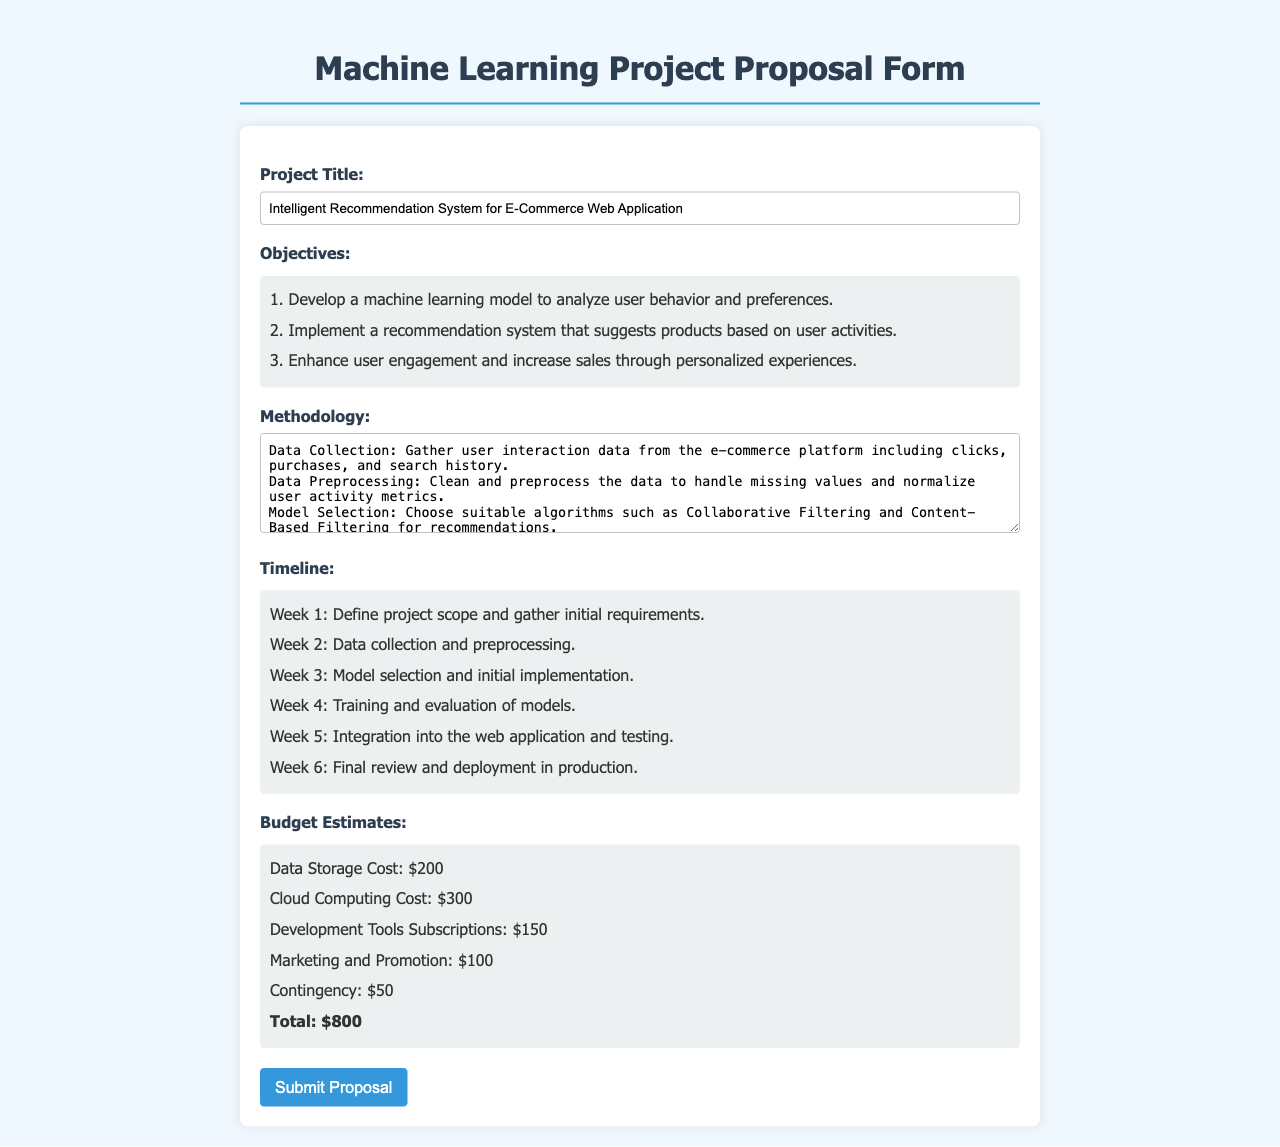What is the project title? The project title is specified in the form under "Project Title:"
Answer: Intelligent Recommendation System for E-Commerce Web Application How many objectives are listed in the proposal? The objectives are listed in a separate section, and there are three items mentioned.
Answer: 3 What is the total budget estimate provided in the proposal? The total budget estimate is given in the budget section, which sums up all costs listed.
Answer: $800 What is the duration of the timeline for the project? The timeline defines activities over a marked period, specifically noted as six weeks.
Answer: 6 weeks Which methods are suggested for model training? The methodology section describes the methods to be used, mentioning specific libraries utilized for training.
Answer: Scikit-Learn and TensorFlow What is the estimated cost for Cloud Computing? The budget section gives exact cost values for each item, including Cloud Computing.
Answer: $300 In which week is model evaluation scheduled? The timeline outlines the weekly tasks, specifically stating when the evaluation takes place.
Answer: Week 4 What is the main aim of the recommendation system as per the objectives? The objectives mention the intentions behind developing the recommendation system, focusing on user engagement and sales.
Answer: Enhance user engagement and increase sales through personalized experiences 